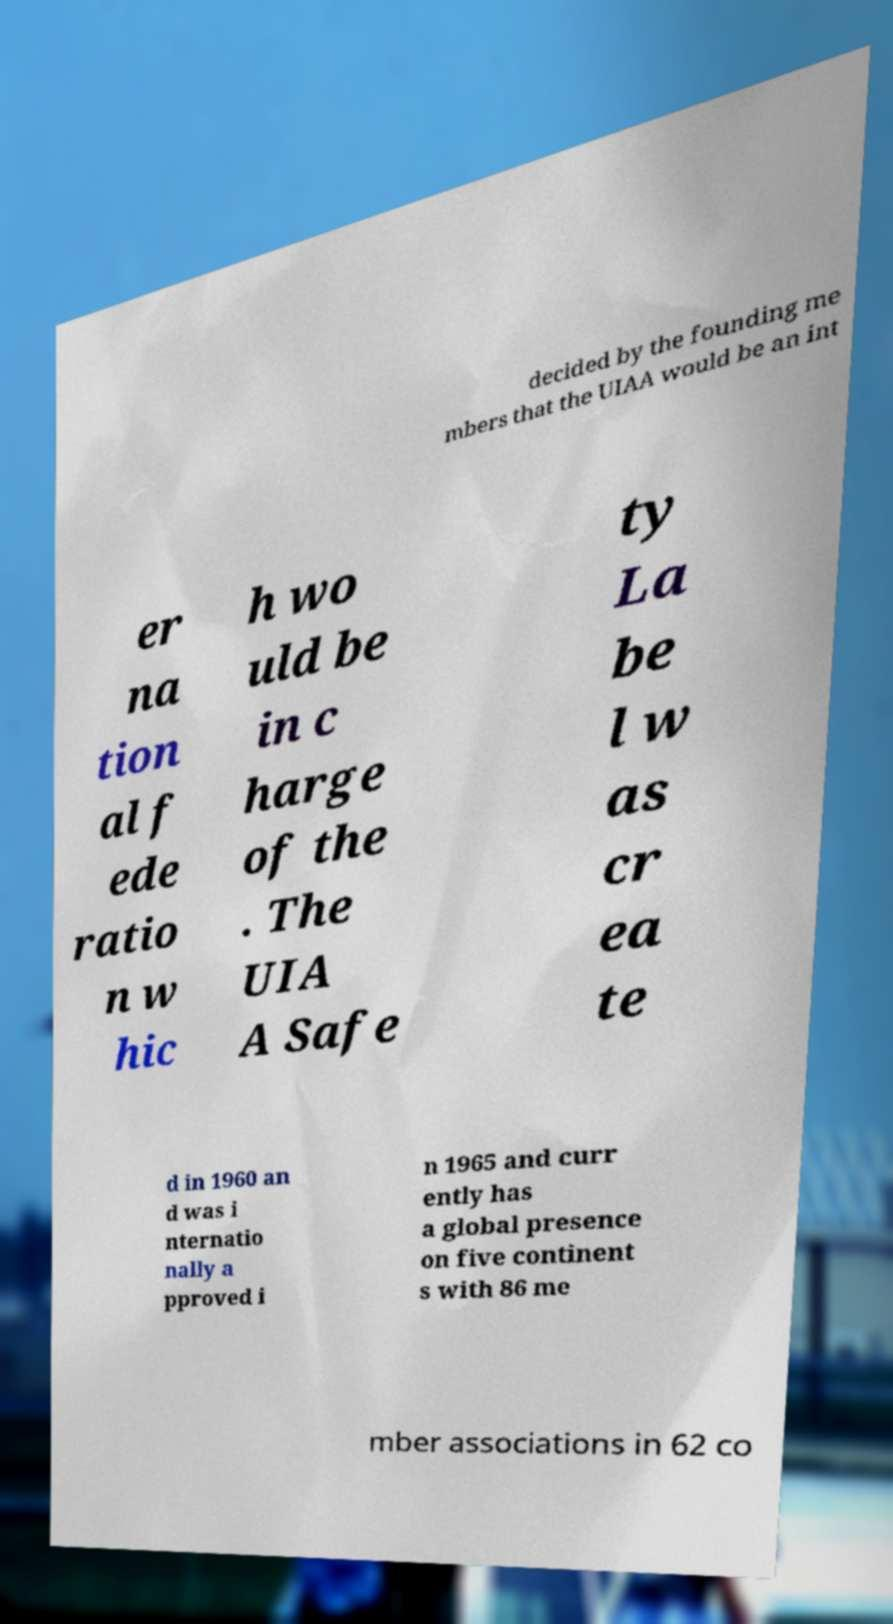Could you assist in decoding the text presented in this image and type it out clearly? decided by the founding me mbers that the UIAA would be an int er na tion al f ede ratio n w hic h wo uld be in c harge of the . The UIA A Safe ty La be l w as cr ea te d in 1960 an d was i nternatio nally a pproved i n 1965 and curr ently has a global presence on five continent s with 86 me mber associations in 62 co 